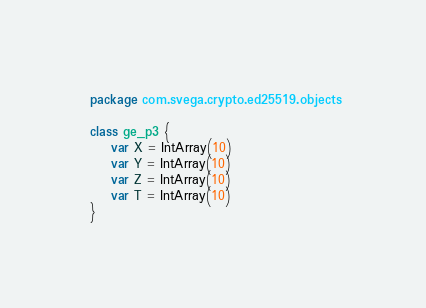<code> <loc_0><loc_0><loc_500><loc_500><_Kotlin_>package com.svega.crypto.ed25519.objects

class ge_p3 {
    var X = IntArray(10)
    var Y = IntArray(10)
    var Z = IntArray(10)
    var T = IntArray(10)
}

</code> 